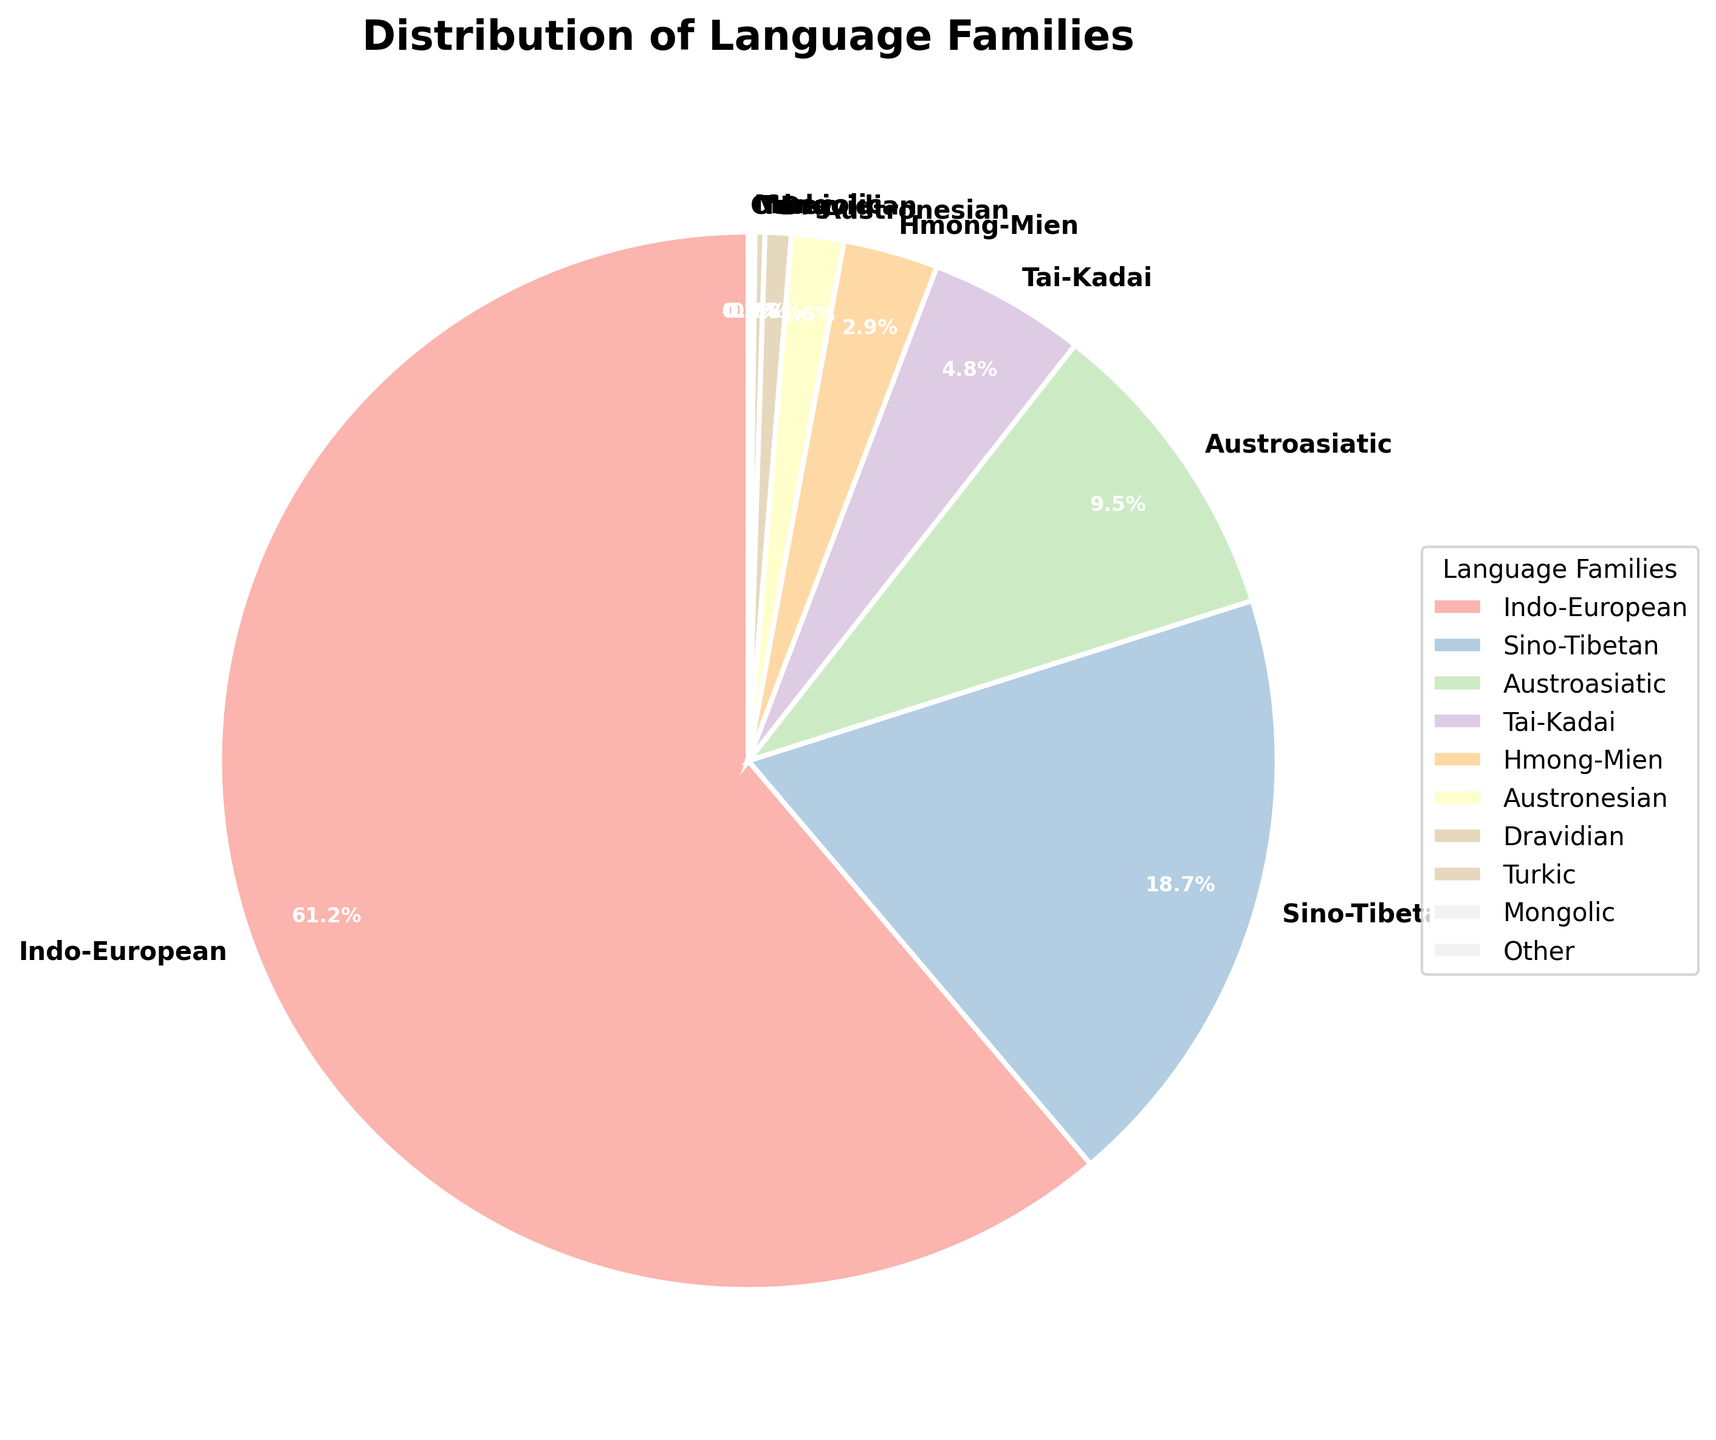What is the largest language family in the visited country? The pie chart shows the largest segment representing the Indo-European language family with 61.2%.
Answer: Indo-European How many language families constitute less than 5% of the total? Summing up the percentages less than 5%: Tai-Kadai (4.8%), Hmong-Mien (2.9%), Austronesian (1.6%), Dravidian (0.8%), Turkic (0.3%), Mongolic (0.1%), and Other (0.1%). We find 7 language families fitting this criterion.
Answer: 7 Which language family is nearly twice as common as Austroasiatic? Austroasiatic has 9.5%. Sino-Tibetan is 18.7%, nearly twice Austroasiatic (as 9.5 x 2 = 19).
Answer: Sino-Tibetan Are there more people speaking languages from the Tai-Kadai family or the Austroasiatic family? Comparing the percentages, Tai-Kadai has 4.8% and Austroasiatic has 9.5%. Austroasiatic is larger.
Answer: Austroasiatic What is the combined percentage of Sino-Tibetan and Austroasiatic language families? Add the percentages: Sino-Tibetan (18.7%) + Austroasiatic (9.5%) = 28.2%.
Answer: 28.2% Which language families have a visual segment in the pie chart smaller than the Turkic family? Turkic has 0.3%. Since Mongolic (0.1%) and Other (0.1%) have lower percentages, they correspond to smaller segments.
Answer: Mongolic, Other What is the visual attribute of the wedge with the smallest percentage? The smallest wedge represents the Mongolic and Other language families, both at 0.1%. Their wedges are narrow and placed at the end of the pie chart near the 90-degree start angle.
Answer: Narrow and at the start angle Which language family has a light pastel color and occupies a significant portion of the chart? Indo-European is indicated by a large segment and represented by a prominent light pastel color.
Answer: Indo-European How much more dominant is the Indo-European family compared to the Austroasiatic family? Subtract Austroasiatic from Indo-European: 61.2% - 9.5% = 51.7%.
Answer: 51.7% 